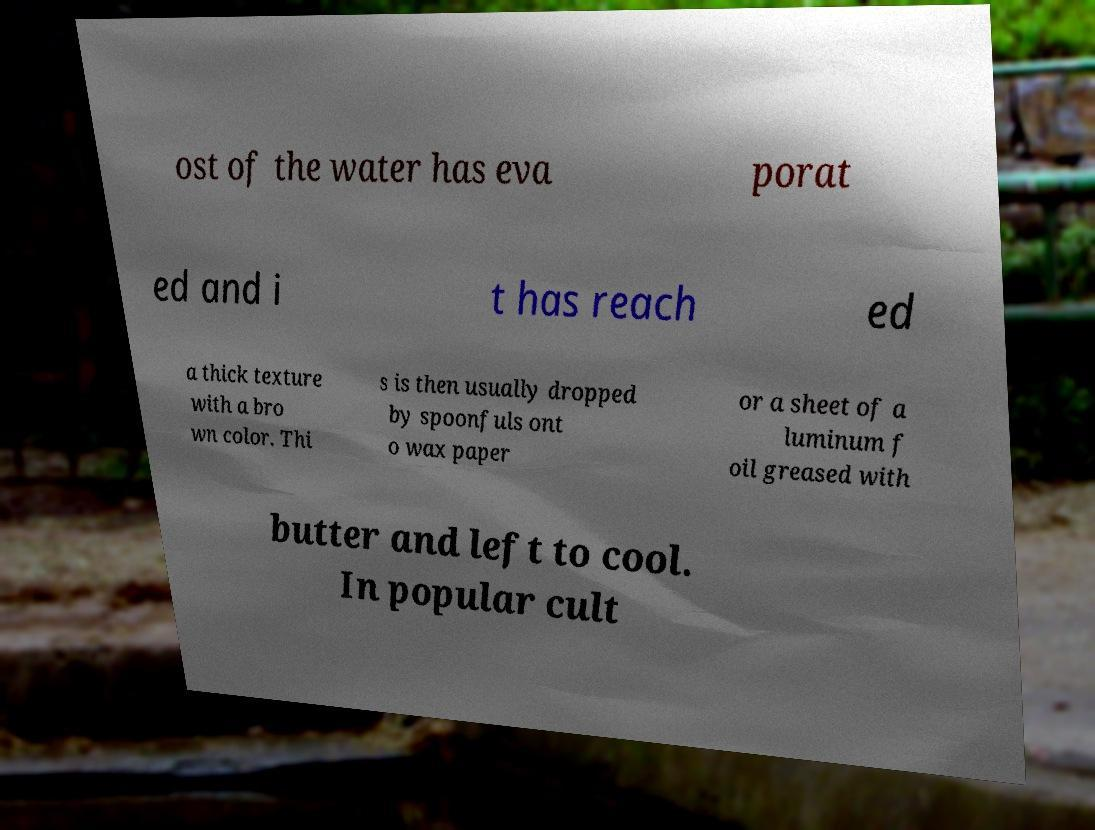Can you accurately transcribe the text from the provided image for me? ost of the water has eva porat ed and i t has reach ed a thick texture with a bro wn color. Thi s is then usually dropped by spoonfuls ont o wax paper or a sheet of a luminum f oil greased with butter and left to cool. In popular cult 